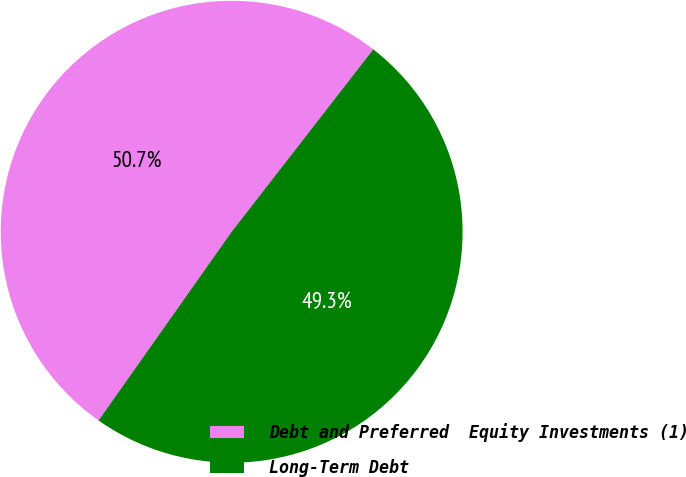<chart> <loc_0><loc_0><loc_500><loc_500><pie_chart><fcel>Debt and Preferred  Equity Investments (1)<fcel>Long-Term Debt<nl><fcel>50.73%<fcel>49.27%<nl></chart> 